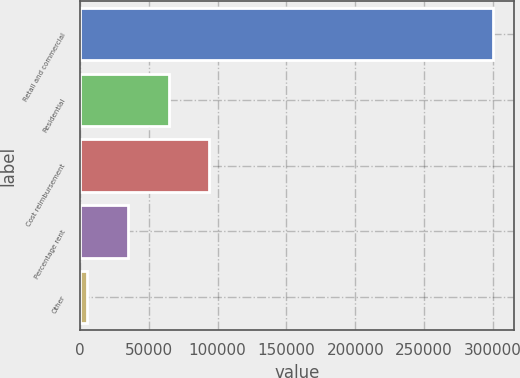Convert chart. <chart><loc_0><loc_0><loc_500><loc_500><bar_chart><fcel>Retail and commercial<fcel>Residential<fcel>Cost reimbursement<fcel>Percentage rent<fcel>Other<nl><fcel>300230<fcel>64366.8<fcel>93849.7<fcel>34883.9<fcel>5401<nl></chart> 